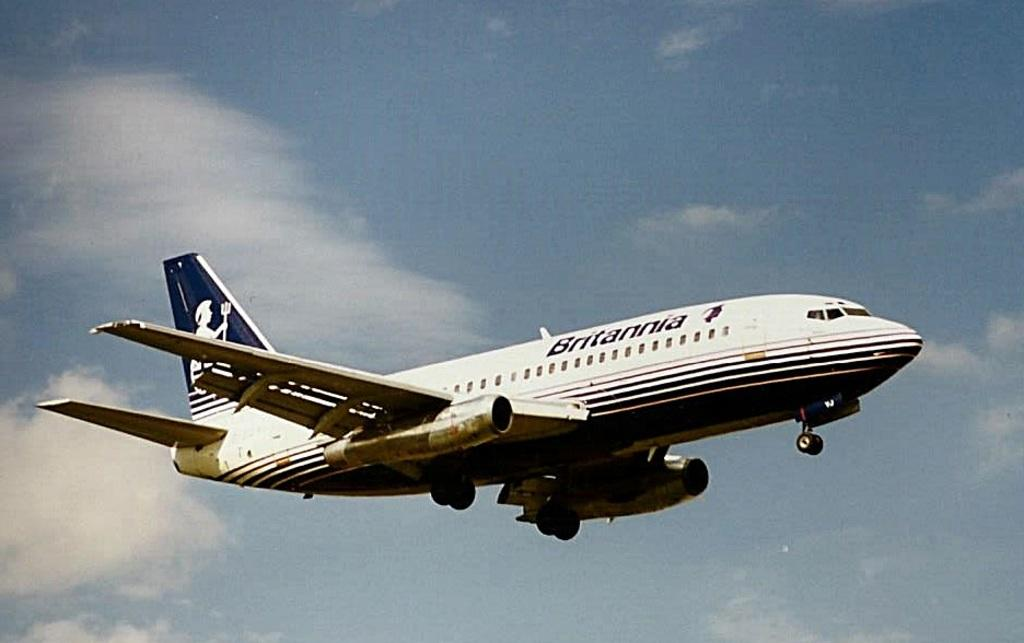What is the main subject of the picture? The main subject of the picture is an aircraft. What is the aircraft doing in the picture? The aircraft is flying in the sky. What can be seen in the sky besides the aircraft? There are clouds in the sky. How many seeds can be seen falling from the aircraft in the image? There are no seeds visible in the image, and the aircraft is not releasing any seeds. 